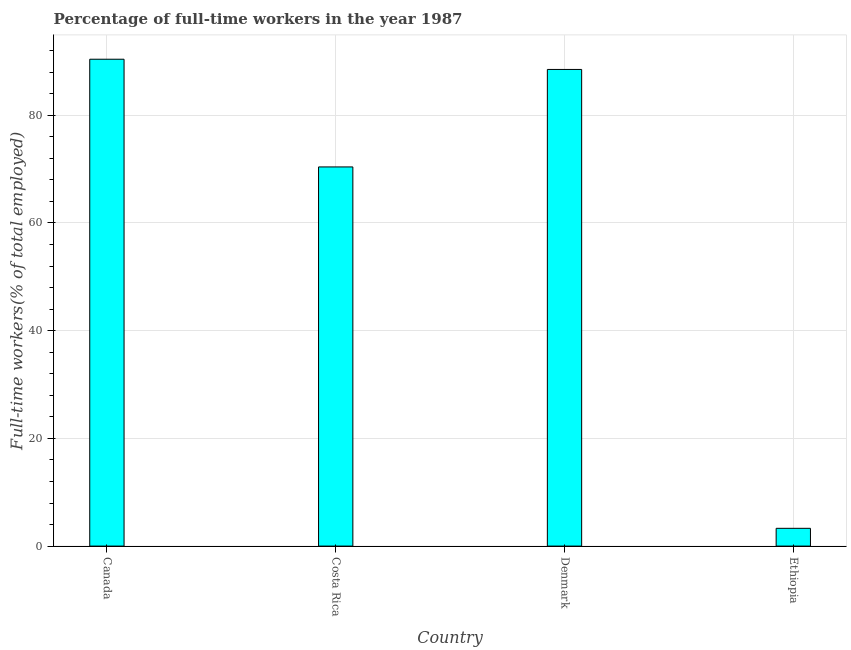What is the title of the graph?
Keep it short and to the point. Percentage of full-time workers in the year 1987. What is the label or title of the X-axis?
Offer a very short reply. Country. What is the label or title of the Y-axis?
Offer a terse response. Full-time workers(% of total employed). What is the percentage of full-time workers in Costa Rica?
Provide a succinct answer. 70.4. Across all countries, what is the maximum percentage of full-time workers?
Provide a succinct answer. 90.4. Across all countries, what is the minimum percentage of full-time workers?
Your answer should be very brief. 3.3. In which country was the percentage of full-time workers maximum?
Your response must be concise. Canada. In which country was the percentage of full-time workers minimum?
Provide a succinct answer. Ethiopia. What is the sum of the percentage of full-time workers?
Ensure brevity in your answer.  252.6. What is the average percentage of full-time workers per country?
Your response must be concise. 63.15. What is the median percentage of full-time workers?
Keep it short and to the point. 79.45. What is the ratio of the percentage of full-time workers in Costa Rica to that in Ethiopia?
Give a very brief answer. 21.33. Is the difference between the percentage of full-time workers in Canada and Costa Rica greater than the difference between any two countries?
Ensure brevity in your answer.  No. What is the difference between the highest and the second highest percentage of full-time workers?
Your answer should be compact. 1.9. What is the difference between the highest and the lowest percentage of full-time workers?
Keep it short and to the point. 87.1. In how many countries, is the percentage of full-time workers greater than the average percentage of full-time workers taken over all countries?
Make the answer very short. 3. Are all the bars in the graph horizontal?
Your answer should be compact. No. How many countries are there in the graph?
Your answer should be compact. 4. What is the difference between two consecutive major ticks on the Y-axis?
Provide a short and direct response. 20. Are the values on the major ticks of Y-axis written in scientific E-notation?
Keep it short and to the point. No. What is the Full-time workers(% of total employed) in Canada?
Keep it short and to the point. 90.4. What is the Full-time workers(% of total employed) in Costa Rica?
Make the answer very short. 70.4. What is the Full-time workers(% of total employed) in Denmark?
Keep it short and to the point. 88.5. What is the Full-time workers(% of total employed) in Ethiopia?
Offer a very short reply. 3.3. What is the difference between the Full-time workers(% of total employed) in Canada and Costa Rica?
Make the answer very short. 20. What is the difference between the Full-time workers(% of total employed) in Canada and Ethiopia?
Offer a terse response. 87.1. What is the difference between the Full-time workers(% of total employed) in Costa Rica and Denmark?
Offer a very short reply. -18.1. What is the difference between the Full-time workers(% of total employed) in Costa Rica and Ethiopia?
Give a very brief answer. 67.1. What is the difference between the Full-time workers(% of total employed) in Denmark and Ethiopia?
Provide a succinct answer. 85.2. What is the ratio of the Full-time workers(% of total employed) in Canada to that in Costa Rica?
Your answer should be very brief. 1.28. What is the ratio of the Full-time workers(% of total employed) in Canada to that in Denmark?
Your answer should be compact. 1.02. What is the ratio of the Full-time workers(% of total employed) in Canada to that in Ethiopia?
Your response must be concise. 27.39. What is the ratio of the Full-time workers(% of total employed) in Costa Rica to that in Denmark?
Provide a succinct answer. 0.8. What is the ratio of the Full-time workers(% of total employed) in Costa Rica to that in Ethiopia?
Your answer should be very brief. 21.33. What is the ratio of the Full-time workers(% of total employed) in Denmark to that in Ethiopia?
Keep it short and to the point. 26.82. 